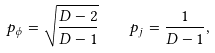Convert formula to latex. <formula><loc_0><loc_0><loc_500><loc_500>p _ { \phi } = \sqrt { \frac { D - 2 } { D - 1 } } \quad p _ { j } = \frac { 1 } { D - 1 } ,</formula> 